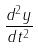<formula> <loc_0><loc_0><loc_500><loc_500>\frac { d ^ { 2 } y } { d t ^ { 2 } }</formula> 